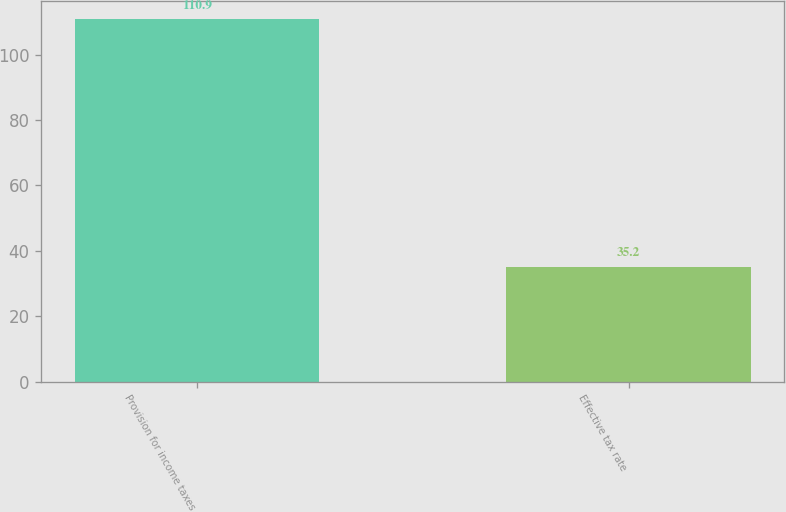Convert chart. <chart><loc_0><loc_0><loc_500><loc_500><bar_chart><fcel>Provision for income taxes<fcel>Effective tax rate<nl><fcel>110.9<fcel>35.2<nl></chart> 